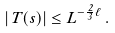<formula> <loc_0><loc_0><loc_500><loc_500>| T ( s ) | \leq L ^ { - \frac { 2 } { 3 } \ell } \, .</formula> 